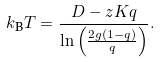Convert formula to latex. <formula><loc_0><loc_0><loc_500><loc_500>k _ { \text {B} } T = \frac { D - z K q } { \ln \left ( \frac { 2 g ( 1 - q ) } { q } \right ) } .</formula> 